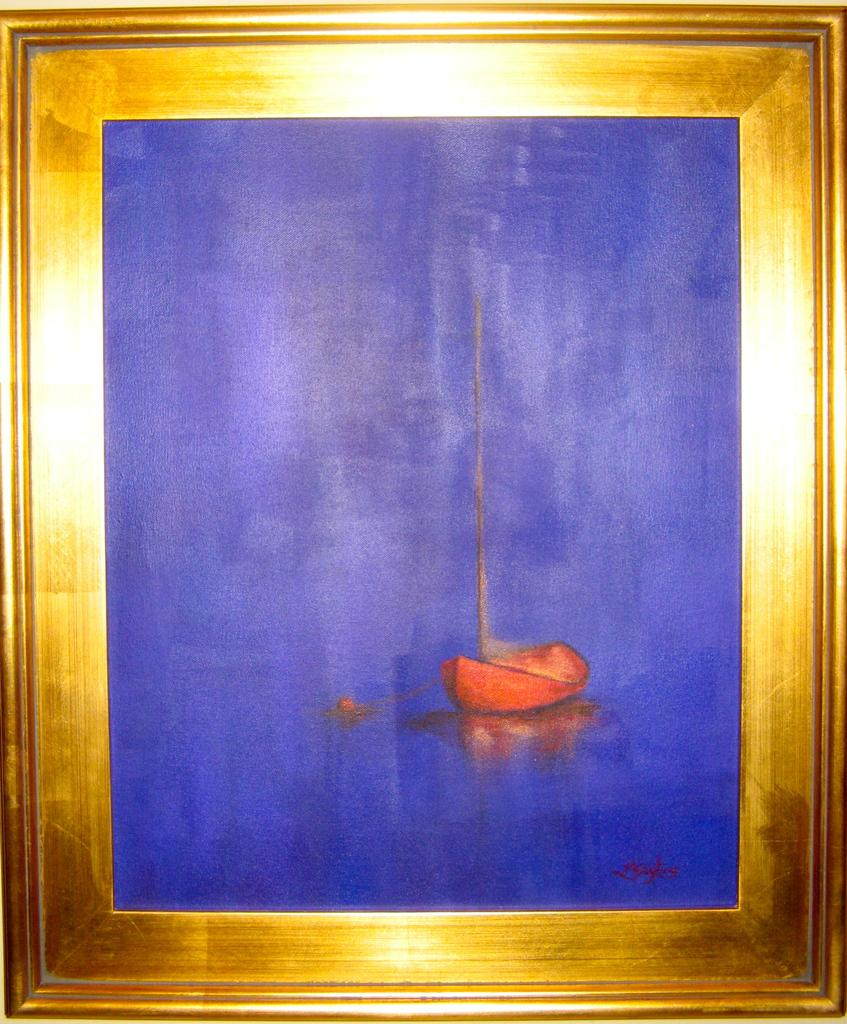What object can be seen in the image? There is a photo frame in the image. What is the color of the photo frame? The photo frame has a blue color. What is depicted inside the photo frame? The photo frame contains a red color boat. Are there any additional design elements on the photo frame? Yes, there are gold color strips around the frame. How does the sky affect the boat's digestion in the image? The image does not depict a sky or any boat digestion; it only shows a photo frame with a red color boat inside. 